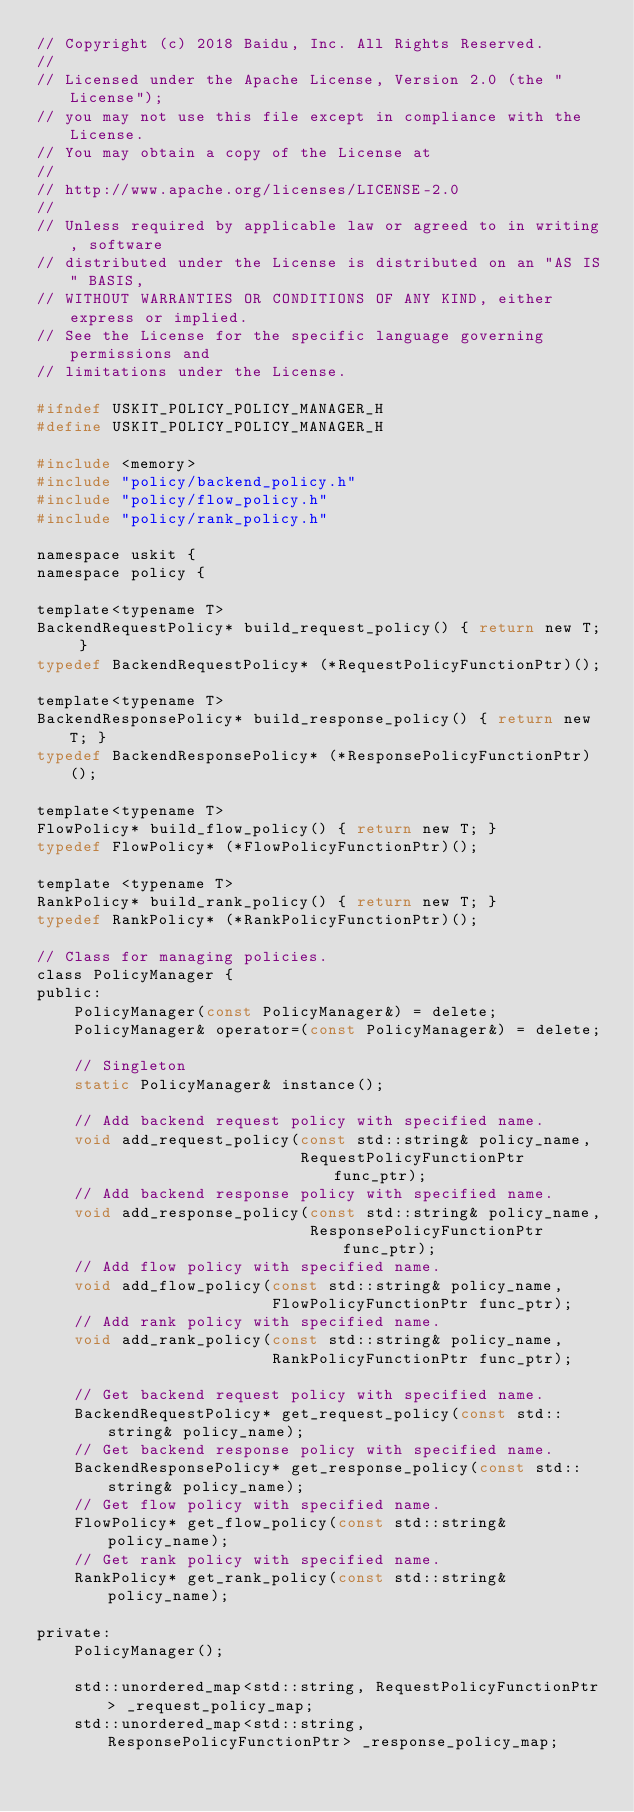<code> <loc_0><loc_0><loc_500><loc_500><_C_>// Copyright (c) 2018 Baidu, Inc. All Rights Reserved.
//
// Licensed under the Apache License, Version 2.0 (the "License");
// you may not use this file except in compliance with the License.
// You may obtain a copy of the License at
//
// http://www.apache.org/licenses/LICENSE-2.0
//
// Unless required by applicable law or agreed to in writing, software
// distributed under the License is distributed on an "AS IS" BASIS,
// WITHOUT WARRANTIES OR CONDITIONS OF ANY KIND, either express or implied.
// See the License for the specific language governing permissions and
// limitations under the License.

#ifndef USKIT_POLICY_POLICY_MANAGER_H
#define USKIT_POLICY_POLICY_MANAGER_H

#include <memory>
#include "policy/backend_policy.h"
#include "policy/flow_policy.h"
#include "policy/rank_policy.h"

namespace uskit {
namespace policy {

template<typename T>
BackendRequestPolicy* build_request_policy() { return new T; }
typedef BackendRequestPolicy* (*RequestPolicyFunctionPtr)();

template<typename T>
BackendResponsePolicy* build_response_policy() { return new T; }
typedef BackendResponsePolicy* (*ResponsePolicyFunctionPtr)();

template<typename T>
FlowPolicy* build_flow_policy() { return new T; }
typedef FlowPolicy* (*FlowPolicyFunctionPtr)();

template <typename T>
RankPolicy* build_rank_policy() { return new T; }
typedef RankPolicy* (*RankPolicyFunctionPtr)();

// Class for managing policies.
class PolicyManager {
public:
    PolicyManager(const PolicyManager&) = delete;
    PolicyManager& operator=(const PolicyManager&) = delete;

    // Singleton
    static PolicyManager& instance();

    // Add backend request policy with specified name.
    void add_request_policy(const std::string& policy_name,
                            RequestPolicyFunctionPtr func_ptr);
    // Add backend response policy with specified name.
    void add_response_policy(const std::string& policy_name,
                             ResponsePolicyFunctionPtr func_ptr);
    // Add flow policy with specified name.
    void add_flow_policy(const std::string& policy_name,
                         FlowPolicyFunctionPtr func_ptr);
    // Add rank policy with specified name.
    void add_rank_policy(const std::string& policy_name,
                         RankPolicyFunctionPtr func_ptr);

    // Get backend request policy with specified name.
    BackendRequestPolicy* get_request_policy(const std::string& policy_name);
    // Get backend response policy with specified name.
    BackendResponsePolicy* get_response_policy(const std::string& policy_name);
    // Get flow policy with specified name.
    FlowPolicy* get_flow_policy(const std::string& policy_name);
    // Get rank policy with specified name.
    RankPolicy* get_rank_policy(const std::string& policy_name);

private:
    PolicyManager();

    std::unordered_map<std::string, RequestPolicyFunctionPtr> _request_policy_map;
    std::unordered_map<std::string, ResponsePolicyFunctionPtr> _response_policy_map;</code> 